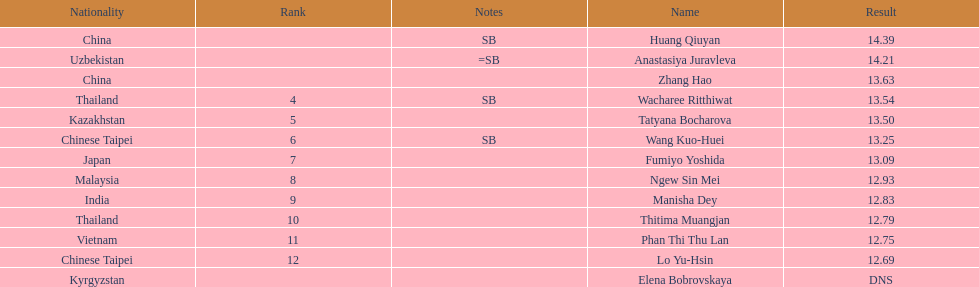How many contestants were from thailand? 2. 